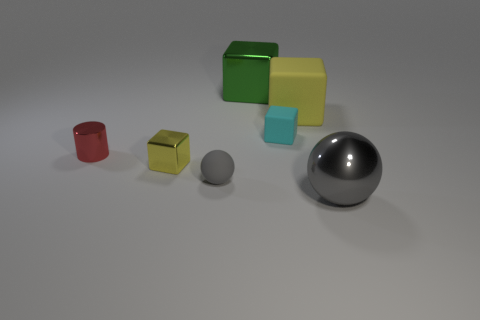Add 1 tiny red cylinders. How many objects exist? 8 Add 7 blue rubber cylinders. How many blue rubber cylinders exist? 7 Subtract all cyan cubes. How many cubes are left? 3 Subtract all small matte cubes. How many cubes are left? 3 Subtract 1 green blocks. How many objects are left? 6 Subtract all cylinders. How many objects are left? 6 Subtract 1 balls. How many balls are left? 1 Subtract all red cubes. Subtract all green cylinders. How many cubes are left? 4 Subtract all blue spheres. How many green blocks are left? 1 Subtract all tiny red balls. Subtract all yellow matte blocks. How many objects are left? 6 